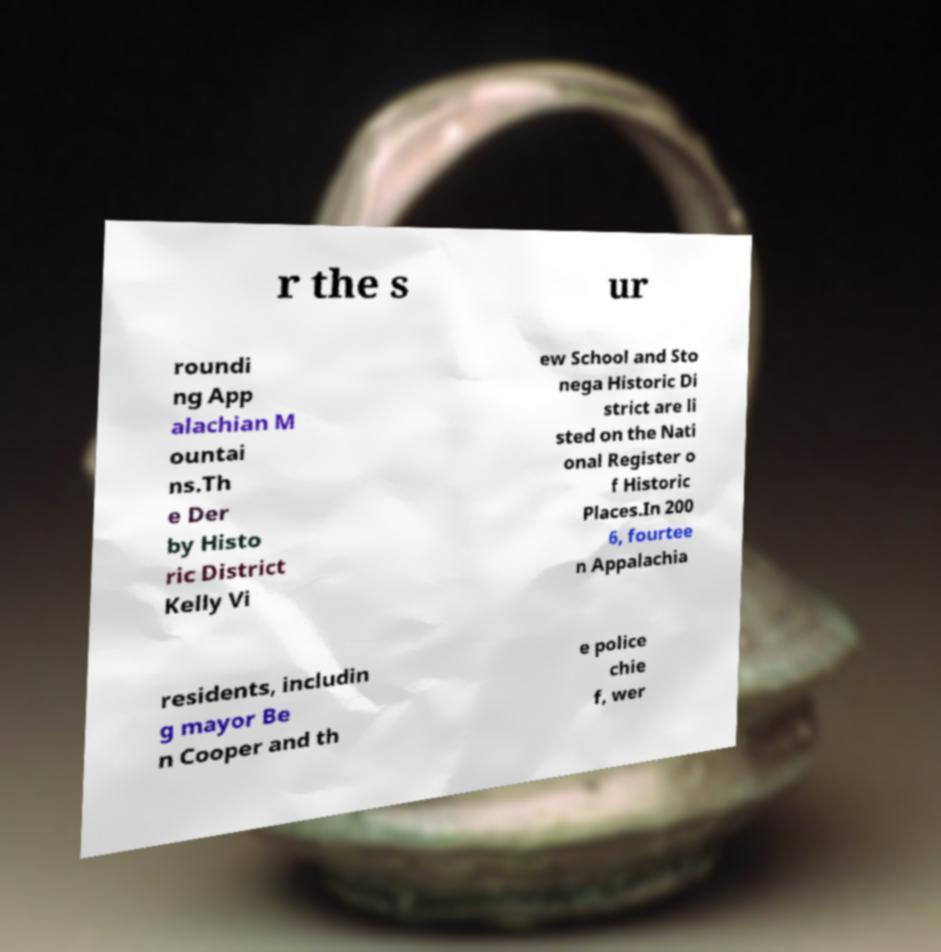For documentation purposes, I need the text within this image transcribed. Could you provide that? r the s ur roundi ng App alachian M ountai ns.Th e Der by Histo ric District Kelly Vi ew School and Sto nega Historic Di strict are li sted on the Nati onal Register o f Historic Places.In 200 6, fourtee n Appalachia residents, includin g mayor Be n Cooper and th e police chie f, wer 